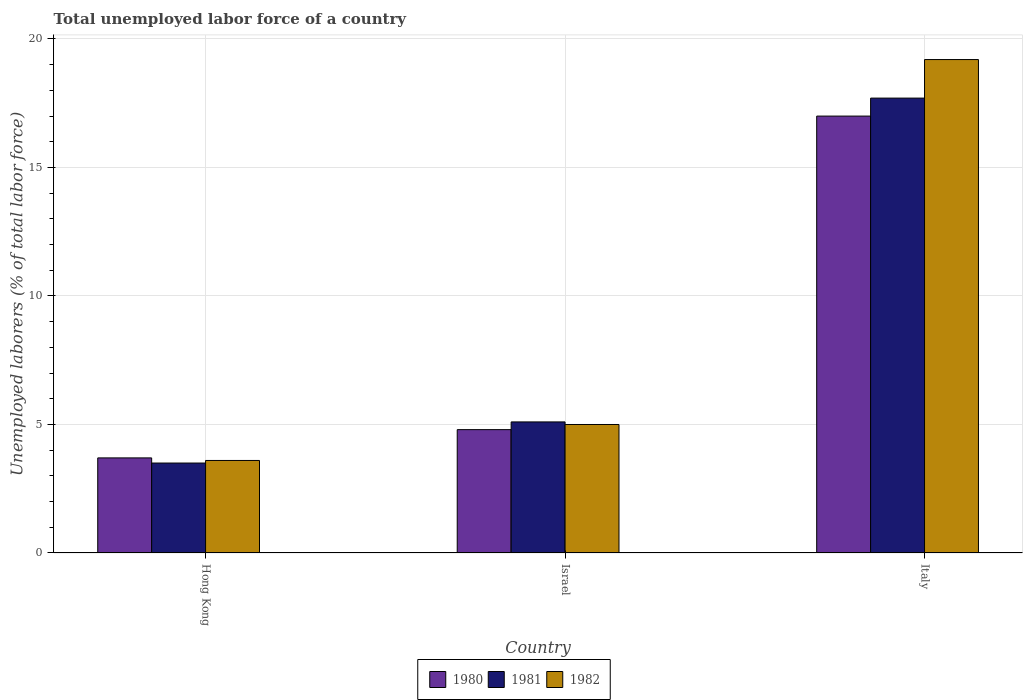How many different coloured bars are there?
Your response must be concise. 3. How many groups of bars are there?
Provide a succinct answer. 3. Are the number of bars on each tick of the X-axis equal?
Your response must be concise. Yes. How many bars are there on the 2nd tick from the left?
Make the answer very short. 3. How many bars are there on the 1st tick from the right?
Make the answer very short. 3. What is the label of the 2nd group of bars from the left?
Give a very brief answer. Israel. In how many cases, is the number of bars for a given country not equal to the number of legend labels?
Provide a short and direct response. 0. What is the total unemployed labor force in 1980 in Israel?
Make the answer very short. 4.8. Across all countries, what is the maximum total unemployed labor force in 1980?
Make the answer very short. 17. In which country was the total unemployed labor force in 1982 minimum?
Provide a short and direct response. Hong Kong. What is the total total unemployed labor force in 1981 in the graph?
Give a very brief answer. 26.3. What is the difference between the total unemployed labor force in 1982 in Hong Kong and that in Italy?
Provide a short and direct response. -15.6. What is the average total unemployed labor force in 1981 per country?
Your answer should be compact. 8.77. What is the difference between the total unemployed labor force of/in 1980 and total unemployed labor force of/in 1982 in Italy?
Provide a succinct answer. -2.2. What is the ratio of the total unemployed labor force in 1982 in Hong Kong to that in Israel?
Your response must be concise. 0.72. Is the difference between the total unemployed labor force in 1980 in Hong Kong and Israel greater than the difference between the total unemployed labor force in 1982 in Hong Kong and Israel?
Give a very brief answer. Yes. What is the difference between the highest and the second highest total unemployed labor force in 1982?
Your response must be concise. -15.6. What is the difference between the highest and the lowest total unemployed labor force in 1980?
Provide a short and direct response. 13.3. In how many countries, is the total unemployed labor force in 1981 greater than the average total unemployed labor force in 1981 taken over all countries?
Your answer should be compact. 1. Is it the case that in every country, the sum of the total unemployed labor force in 1981 and total unemployed labor force in 1980 is greater than the total unemployed labor force in 1982?
Provide a succinct answer. Yes. How many bars are there?
Your response must be concise. 9. How many countries are there in the graph?
Your answer should be very brief. 3. What is the difference between two consecutive major ticks on the Y-axis?
Your answer should be very brief. 5. Does the graph contain grids?
Provide a succinct answer. Yes. How many legend labels are there?
Provide a succinct answer. 3. What is the title of the graph?
Your response must be concise. Total unemployed labor force of a country. What is the label or title of the X-axis?
Make the answer very short. Country. What is the label or title of the Y-axis?
Your answer should be compact. Unemployed laborers (% of total labor force). What is the Unemployed laborers (% of total labor force) in 1980 in Hong Kong?
Your answer should be very brief. 3.7. What is the Unemployed laborers (% of total labor force) in 1982 in Hong Kong?
Provide a short and direct response. 3.6. What is the Unemployed laborers (% of total labor force) of 1980 in Israel?
Keep it short and to the point. 4.8. What is the Unemployed laborers (% of total labor force) in 1981 in Israel?
Keep it short and to the point. 5.1. What is the Unemployed laborers (% of total labor force) of 1982 in Israel?
Provide a succinct answer. 5. What is the Unemployed laborers (% of total labor force) in 1980 in Italy?
Ensure brevity in your answer.  17. What is the Unemployed laborers (% of total labor force) in 1981 in Italy?
Your answer should be compact. 17.7. What is the Unemployed laborers (% of total labor force) in 1982 in Italy?
Provide a short and direct response. 19.2. Across all countries, what is the maximum Unemployed laborers (% of total labor force) in 1980?
Ensure brevity in your answer.  17. Across all countries, what is the maximum Unemployed laborers (% of total labor force) in 1981?
Give a very brief answer. 17.7. Across all countries, what is the maximum Unemployed laborers (% of total labor force) in 1982?
Your answer should be compact. 19.2. Across all countries, what is the minimum Unemployed laborers (% of total labor force) in 1980?
Give a very brief answer. 3.7. Across all countries, what is the minimum Unemployed laborers (% of total labor force) in 1982?
Offer a terse response. 3.6. What is the total Unemployed laborers (% of total labor force) of 1981 in the graph?
Provide a short and direct response. 26.3. What is the total Unemployed laborers (% of total labor force) in 1982 in the graph?
Your answer should be compact. 27.8. What is the difference between the Unemployed laborers (% of total labor force) of 1982 in Hong Kong and that in Israel?
Your response must be concise. -1.4. What is the difference between the Unemployed laborers (% of total labor force) in 1980 in Hong Kong and that in Italy?
Your answer should be compact. -13.3. What is the difference between the Unemployed laborers (% of total labor force) in 1981 in Hong Kong and that in Italy?
Ensure brevity in your answer.  -14.2. What is the difference between the Unemployed laborers (% of total labor force) of 1982 in Hong Kong and that in Italy?
Give a very brief answer. -15.6. What is the difference between the Unemployed laborers (% of total labor force) of 1981 in Israel and that in Italy?
Offer a very short reply. -12.6. What is the difference between the Unemployed laborers (% of total labor force) in 1982 in Israel and that in Italy?
Ensure brevity in your answer.  -14.2. What is the difference between the Unemployed laborers (% of total labor force) of 1980 in Hong Kong and the Unemployed laborers (% of total labor force) of 1982 in Israel?
Provide a succinct answer. -1.3. What is the difference between the Unemployed laborers (% of total labor force) of 1981 in Hong Kong and the Unemployed laborers (% of total labor force) of 1982 in Israel?
Ensure brevity in your answer.  -1.5. What is the difference between the Unemployed laborers (% of total labor force) in 1980 in Hong Kong and the Unemployed laborers (% of total labor force) in 1981 in Italy?
Keep it short and to the point. -14. What is the difference between the Unemployed laborers (% of total labor force) in 1980 in Hong Kong and the Unemployed laborers (% of total labor force) in 1982 in Italy?
Offer a very short reply. -15.5. What is the difference between the Unemployed laborers (% of total labor force) of 1981 in Hong Kong and the Unemployed laborers (% of total labor force) of 1982 in Italy?
Offer a very short reply. -15.7. What is the difference between the Unemployed laborers (% of total labor force) in 1980 in Israel and the Unemployed laborers (% of total labor force) in 1981 in Italy?
Provide a succinct answer. -12.9. What is the difference between the Unemployed laborers (% of total labor force) of 1980 in Israel and the Unemployed laborers (% of total labor force) of 1982 in Italy?
Your response must be concise. -14.4. What is the difference between the Unemployed laborers (% of total labor force) of 1981 in Israel and the Unemployed laborers (% of total labor force) of 1982 in Italy?
Make the answer very short. -14.1. What is the average Unemployed laborers (% of total labor force) of 1980 per country?
Offer a very short reply. 8.5. What is the average Unemployed laborers (% of total labor force) in 1981 per country?
Your answer should be compact. 8.77. What is the average Unemployed laborers (% of total labor force) in 1982 per country?
Keep it short and to the point. 9.27. What is the difference between the Unemployed laborers (% of total labor force) of 1980 and Unemployed laborers (% of total labor force) of 1981 in Hong Kong?
Offer a very short reply. 0.2. What is the difference between the Unemployed laborers (% of total labor force) in 1980 and Unemployed laborers (% of total labor force) in 1982 in Hong Kong?
Ensure brevity in your answer.  0.1. What is the difference between the Unemployed laborers (% of total labor force) in 1981 and Unemployed laborers (% of total labor force) in 1982 in Hong Kong?
Make the answer very short. -0.1. What is the difference between the Unemployed laborers (% of total labor force) of 1980 and Unemployed laborers (% of total labor force) of 1982 in Israel?
Your response must be concise. -0.2. What is the difference between the Unemployed laborers (% of total labor force) in 1981 and Unemployed laborers (% of total labor force) in 1982 in Israel?
Keep it short and to the point. 0.1. What is the difference between the Unemployed laborers (% of total labor force) of 1980 and Unemployed laborers (% of total labor force) of 1981 in Italy?
Provide a succinct answer. -0.7. What is the difference between the Unemployed laborers (% of total labor force) in 1980 and Unemployed laborers (% of total labor force) in 1982 in Italy?
Offer a terse response. -2.2. What is the difference between the Unemployed laborers (% of total labor force) in 1981 and Unemployed laborers (% of total labor force) in 1982 in Italy?
Provide a succinct answer. -1.5. What is the ratio of the Unemployed laborers (% of total labor force) in 1980 in Hong Kong to that in Israel?
Your answer should be compact. 0.77. What is the ratio of the Unemployed laborers (% of total labor force) of 1981 in Hong Kong to that in Israel?
Offer a terse response. 0.69. What is the ratio of the Unemployed laborers (% of total labor force) of 1982 in Hong Kong to that in Israel?
Give a very brief answer. 0.72. What is the ratio of the Unemployed laborers (% of total labor force) of 1980 in Hong Kong to that in Italy?
Keep it short and to the point. 0.22. What is the ratio of the Unemployed laborers (% of total labor force) in 1981 in Hong Kong to that in Italy?
Provide a short and direct response. 0.2. What is the ratio of the Unemployed laborers (% of total labor force) in 1982 in Hong Kong to that in Italy?
Offer a terse response. 0.19. What is the ratio of the Unemployed laborers (% of total labor force) of 1980 in Israel to that in Italy?
Provide a succinct answer. 0.28. What is the ratio of the Unemployed laborers (% of total labor force) in 1981 in Israel to that in Italy?
Make the answer very short. 0.29. What is the ratio of the Unemployed laborers (% of total labor force) in 1982 in Israel to that in Italy?
Keep it short and to the point. 0.26. What is the difference between the highest and the second highest Unemployed laborers (% of total labor force) in 1981?
Offer a very short reply. 12.6. What is the difference between the highest and the lowest Unemployed laborers (% of total labor force) in 1980?
Offer a very short reply. 13.3. What is the difference between the highest and the lowest Unemployed laborers (% of total labor force) in 1981?
Offer a very short reply. 14.2. 